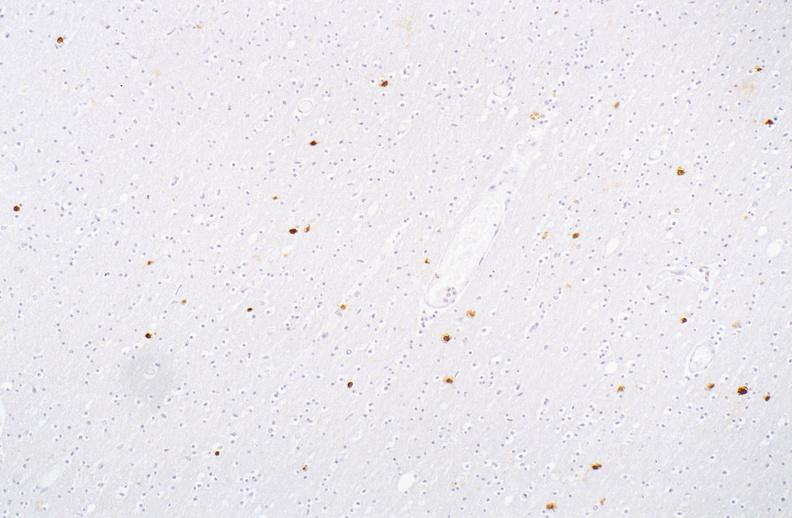what is present?
Answer the question using a single word or phrase. Nervous 